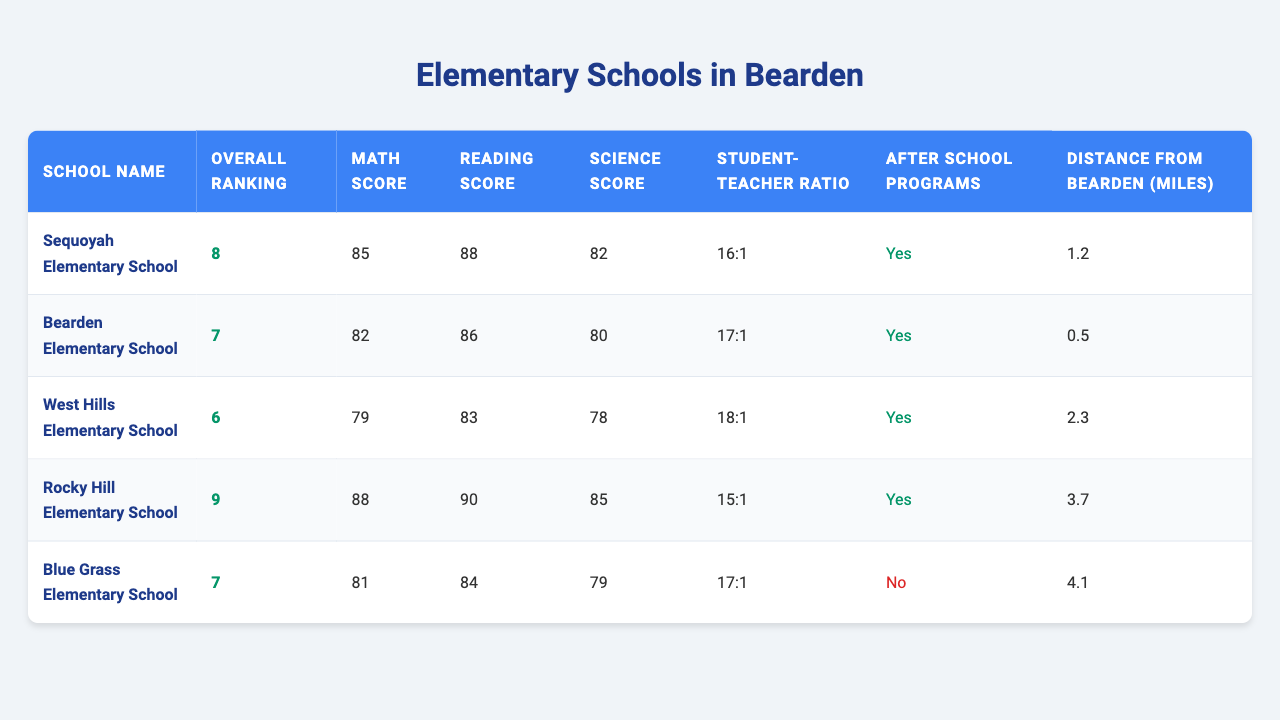What is the overall ranking of Sequoyah Elementary School? The table lists Sequoyah Elementary School, which has an overall ranking of 8.
Answer: 8 Which school has the highest math score? By comparing the math scores for each school in the table, Rocky Hill Elementary School has the highest score at 88.
Answer: Rocky Hill Elementary School Is there an after-school program available at Blue Grass Elementary School? The table indicates that Blue Grass Elementary School does not have an after-school program available (marked as "No").
Answer: No What is the distance from Bearden to West Hills Elementary School? The table specifies that the distance from Bearden to West Hills Elementary School is 2.3 miles.
Answer: 2.3 miles Which school has the lowest overall ranking? When reviewing the overall rankings, Rocky Hill Elementary School ranks 9th, making it the lowest overall ranking among those listed.
Answer: Rocky Hill Elementary School What is the average reading score of all the schools? To find the average reading score, sum the reading scores: (88 + 86 + 83 + 90 + 84) = 431. The average is then calculated by dividing by the number of schools (5), giving 431/5 = 86.2.
Answer: 86.2 Which school has the best student-teacher ratio? The student-teacher ratios of the schools are 16:1 (Sequoyah), 17:1 (Bearden), 18:1 (West Hills), 15:1 (Rocky Hill), and 17:1 (Blue Grass). Rocky Hill Elementary School has the best ratio at 15:1.
Answer: Rocky Hill Elementary School Are after-school programs available at all highly ranked schools (ranked 6 and above)? Examining the rankings and the after-school program availability: Sequoyah (Yes), Bearden (Yes), West Hills (Yes), and Rocky Hill (Yes) all have programs, confirming that all of them have after-school options.
Answer: Yes What is the difference in science scores between the highest and lowest scoring schools? The highest science score is from Rocky Hill Elementary School at 85, while the lowest score is from West Hills Elementary School at 78. The difference is 85 - 78 = 7.
Answer: 7 How many schools have a distance from Bearden greater than 2 miles? The table shows West Hills (2.3 miles) and Rocky Hill (3.7 miles) are both greater than 2 miles. Thus, there are 2 schools that meet this criterion.
Answer: 2 